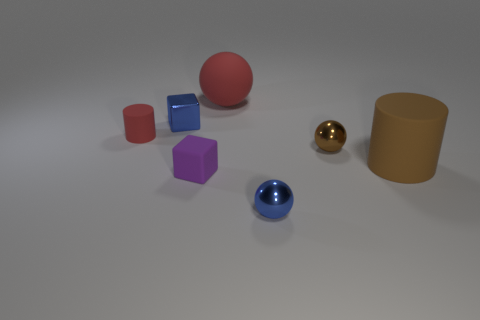Subtract all metallic balls. How many balls are left? 1 Add 1 gray metallic spheres. How many objects exist? 8 Subtract all red balls. How many balls are left? 2 Subtract all cylinders. How many objects are left? 5 Add 7 tiny rubber objects. How many tiny rubber objects exist? 9 Subtract 0 yellow spheres. How many objects are left? 7 Subtract all green blocks. Subtract all yellow cylinders. How many blocks are left? 2 Subtract all tiny blue things. Subtract all small blue shiny objects. How many objects are left? 3 Add 1 tiny matte cylinders. How many tiny matte cylinders are left? 2 